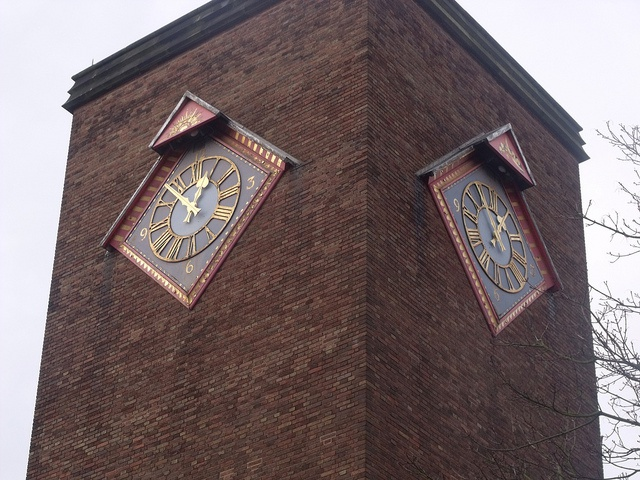Describe the objects in this image and their specific colors. I can see clock in lavender, darkgray, gray, tan, and black tones and clock in lavender, gray, darkgray, and black tones in this image. 